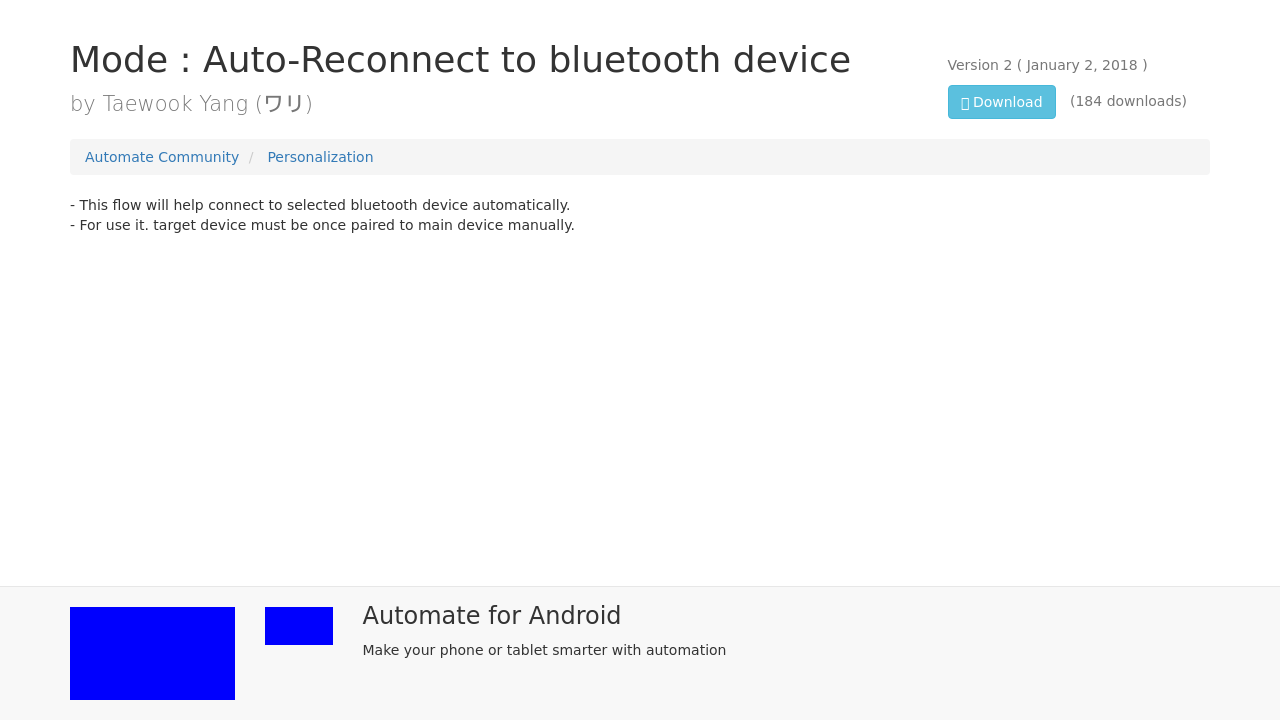Can you explain the primary feature of the software highlighted by the text 'Mode: Auto-Reconnect to bluetooth device'? The text 'Mode: Auto-Reconnect to bluetooth device' suggests that the software has a feature which automatically reconnects to a chosen Bluetooth device. It implies the software can detect when a previously paired Bluetooth device is in range and re-establish a connection without manual intervention, ensuring continuous connectivity. 